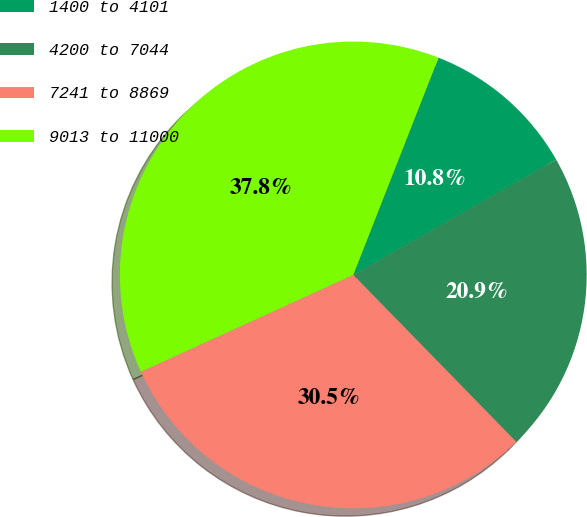<chart> <loc_0><loc_0><loc_500><loc_500><pie_chart><fcel>1400 to 4101<fcel>4200 to 7044<fcel>7241 to 8869<fcel>9013 to 11000<nl><fcel>10.83%<fcel>20.91%<fcel>30.5%<fcel>37.76%<nl></chart> 